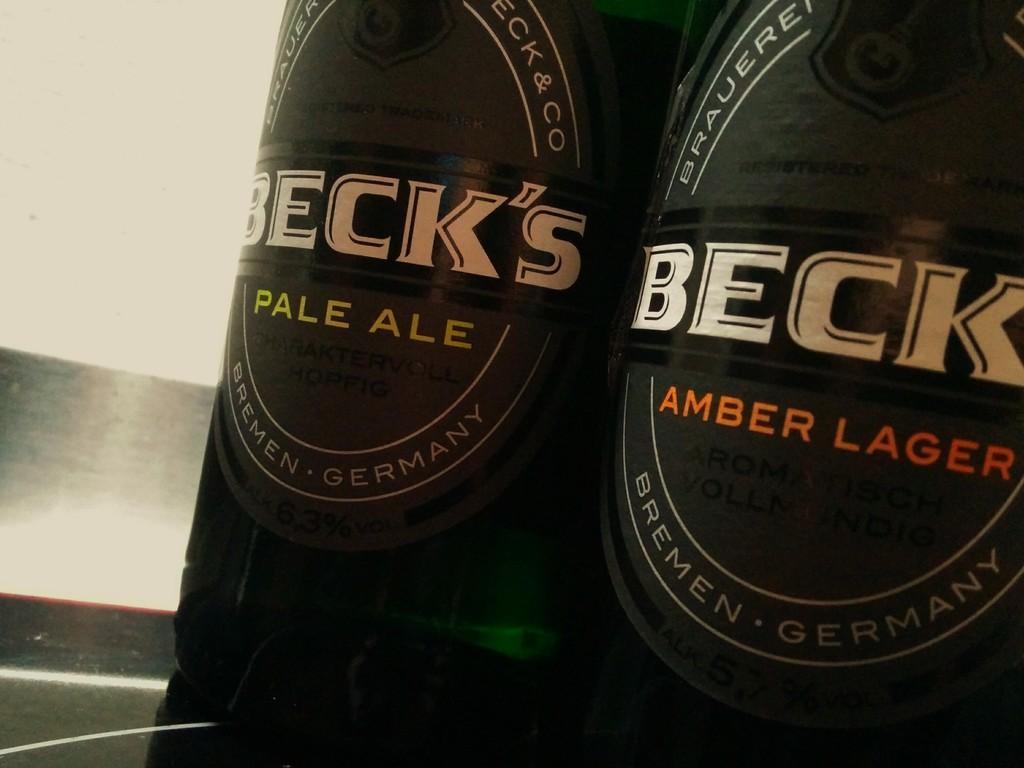In one or two sentences, can you explain what this image depicts? In this picture we can see two bottles here, we can see stickers pasted on these bottles. 